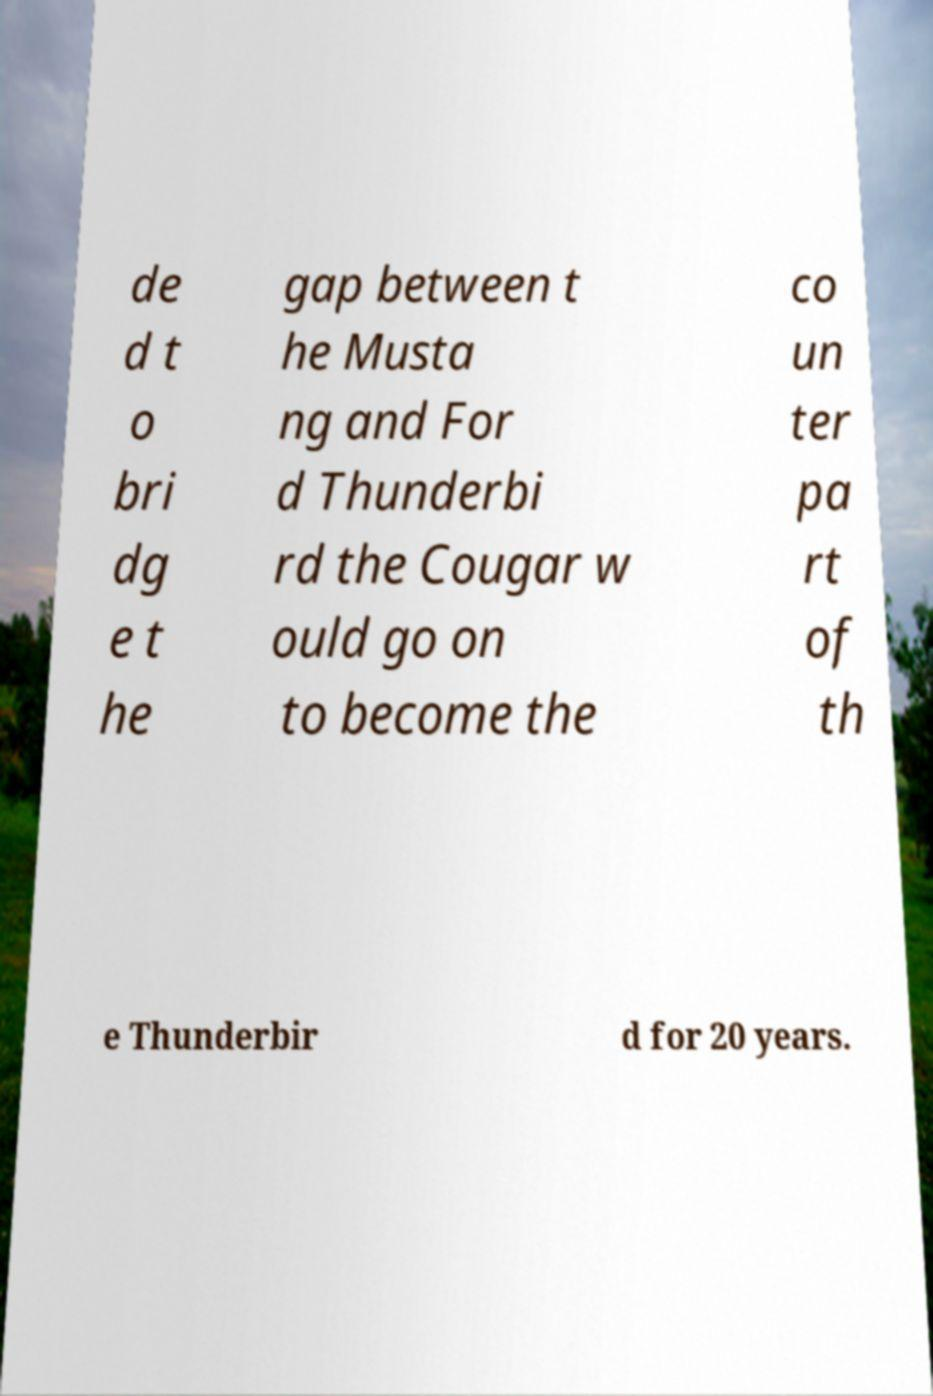For documentation purposes, I need the text within this image transcribed. Could you provide that? de d t o bri dg e t he gap between t he Musta ng and For d Thunderbi rd the Cougar w ould go on to become the co un ter pa rt of th e Thunderbir d for 20 years. 